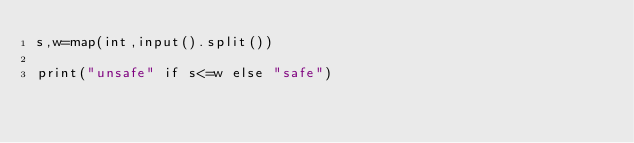<code> <loc_0><loc_0><loc_500><loc_500><_Python_>s,w=map(int,input().split())

print("unsafe" if s<=w else "safe")</code> 